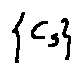<formula> <loc_0><loc_0><loc_500><loc_500>\{ c _ { s } \}</formula> 